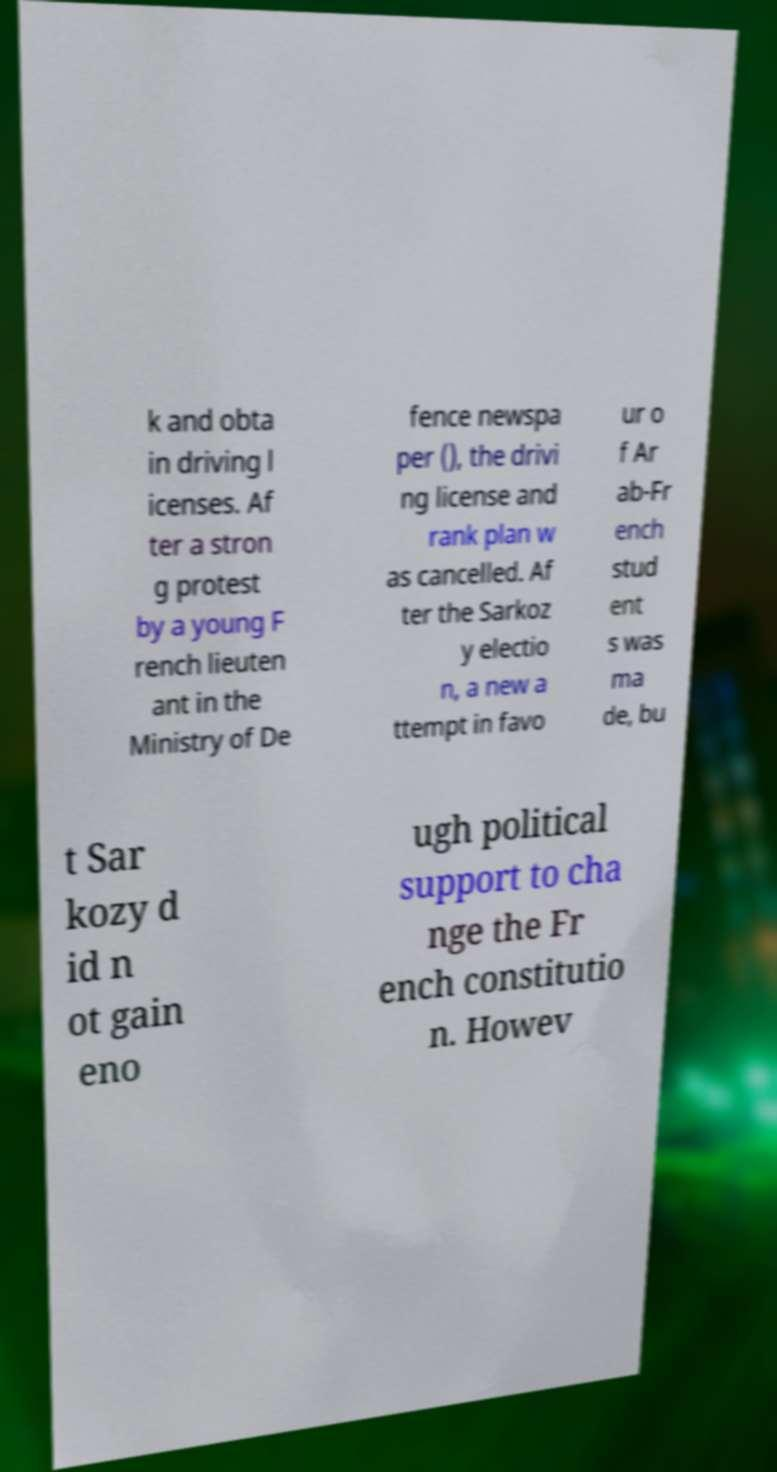Please read and relay the text visible in this image. What does it say? k and obta in driving l icenses. Af ter a stron g protest by a young F rench lieuten ant in the Ministry of De fence newspa per (), the drivi ng license and rank plan w as cancelled. Af ter the Sarkoz y electio n, a new a ttempt in favo ur o f Ar ab-Fr ench stud ent s was ma de, bu t Sar kozy d id n ot gain eno ugh political support to cha nge the Fr ench constitutio n. Howev 